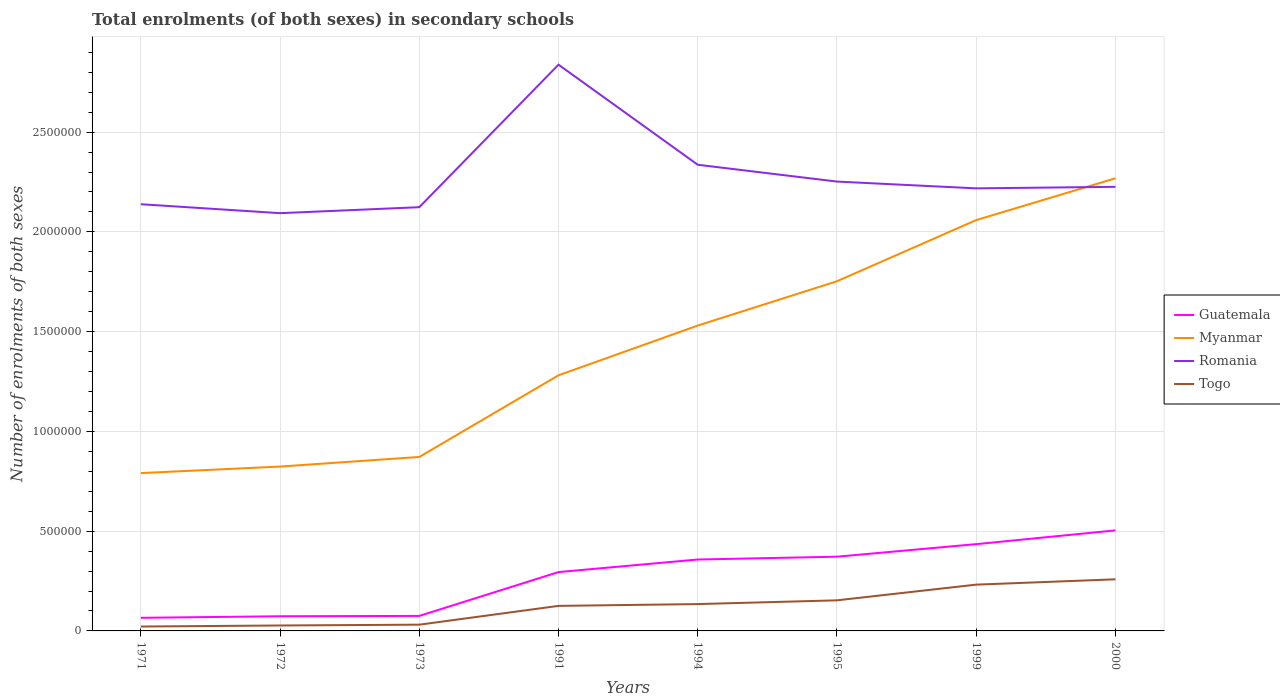How many different coloured lines are there?
Your response must be concise. 4. Does the line corresponding to Myanmar intersect with the line corresponding to Romania?
Your answer should be very brief. Yes. Across all years, what is the maximum number of enrolments in secondary schools in Togo?
Give a very brief answer. 2.20e+04. What is the total number of enrolments in secondary schools in Myanmar in the graph?
Your response must be concise. -8.81e+05. What is the difference between the highest and the second highest number of enrolments in secondary schools in Romania?
Your answer should be compact. 7.44e+05. What is the difference between the highest and the lowest number of enrolments in secondary schools in Myanmar?
Provide a short and direct response. 4. How many lines are there?
Your response must be concise. 4. Does the graph contain grids?
Your answer should be compact. Yes. Where does the legend appear in the graph?
Make the answer very short. Center right. How many legend labels are there?
Your answer should be compact. 4. How are the legend labels stacked?
Your answer should be very brief. Vertical. What is the title of the graph?
Your answer should be compact. Total enrolments (of both sexes) in secondary schools. What is the label or title of the Y-axis?
Give a very brief answer. Number of enrolments of both sexes. What is the Number of enrolments of both sexes of Guatemala in 1971?
Ensure brevity in your answer.  6.57e+04. What is the Number of enrolments of both sexes in Myanmar in 1971?
Your answer should be very brief. 7.91e+05. What is the Number of enrolments of both sexes in Romania in 1971?
Your answer should be compact. 2.14e+06. What is the Number of enrolments of both sexes in Togo in 1971?
Your answer should be compact. 2.20e+04. What is the Number of enrolments of both sexes of Guatemala in 1972?
Provide a short and direct response. 7.35e+04. What is the Number of enrolments of both sexes in Myanmar in 1972?
Your response must be concise. 8.24e+05. What is the Number of enrolments of both sexes of Romania in 1972?
Provide a succinct answer. 2.09e+06. What is the Number of enrolments of both sexes in Togo in 1972?
Provide a short and direct response. 2.73e+04. What is the Number of enrolments of both sexes of Guatemala in 1973?
Give a very brief answer. 7.52e+04. What is the Number of enrolments of both sexes in Myanmar in 1973?
Give a very brief answer. 8.72e+05. What is the Number of enrolments of both sexes of Romania in 1973?
Your answer should be very brief. 2.12e+06. What is the Number of enrolments of both sexes of Togo in 1973?
Give a very brief answer. 3.13e+04. What is the Number of enrolments of both sexes of Guatemala in 1991?
Your answer should be very brief. 2.95e+05. What is the Number of enrolments of both sexes of Myanmar in 1991?
Offer a terse response. 1.28e+06. What is the Number of enrolments of both sexes in Romania in 1991?
Give a very brief answer. 2.84e+06. What is the Number of enrolments of both sexes in Togo in 1991?
Offer a very short reply. 1.26e+05. What is the Number of enrolments of both sexes of Guatemala in 1994?
Provide a succinct answer. 3.58e+05. What is the Number of enrolments of both sexes of Myanmar in 1994?
Provide a succinct answer. 1.53e+06. What is the Number of enrolments of both sexes in Romania in 1994?
Make the answer very short. 2.34e+06. What is the Number of enrolments of both sexes in Togo in 1994?
Keep it short and to the point. 1.35e+05. What is the Number of enrolments of both sexes in Guatemala in 1995?
Ensure brevity in your answer.  3.72e+05. What is the Number of enrolments of both sexes in Myanmar in 1995?
Give a very brief answer. 1.75e+06. What is the Number of enrolments of both sexes of Romania in 1995?
Give a very brief answer. 2.25e+06. What is the Number of enrolments of both sexes of Togo in 1995?
Make the answer very short. 1.53e+05. What is the Number of enrolments of both sexes in Guatemala in 1999?
Keep it short and to the point. 4.35e+05. What is the Number of enrolments of both sexes of Myanmar in 1999?
Your answer should be very brief. 2.06e+06. What is the Number of enrolments of both sexes of Romania in 1999?
Your response must be concise. 2.22e+06. What is the Number of enrolments of both sexes in Togo in 1999?
Offer a very short reply. 2.32e+05. What is the Number of enrolments of both sexes in Guatemala in 2000?
Give a very brief answer. 5.04e+05. What is the Number of enrolments of both sexes of Myanmar in 2000?
Provide a succinct answer. 2.27e+06. What is the Number of enrolments of both sexes of Romania in 2000?
Your answer should be very brief. 2.23e+06. What is the Number of enrolments of both sexes in Togo in 2000?
Your answer should be compact. 2.59e+05. Across all years, what is the maximum Number of enrolments of both sexes of Guatemala?
Provide a short and direct response. 5.04e+05. Across all years, what is the maximum Number of enrolments of both sexes in Myanmar?
Make the answer very short. 2.27e+06. Across all years, what is the maximum Number of enrolments of both sexes in Romania?
Keep it short and to the point. 2.84e+06. Across all years, what is the maximum Number of enrolments of both sexes of Togo?
Offer a terse response. 2.59e+05. Across all years, what is the minimum Number of enrolments of both sexes of Guatemala?
Your answer should be very brief. 6.57e+04. Across all years, what is the minimum Number of enrolments of both sexes of Myanmar?
Ensure brevity in your answer.  7.91e+05. Across all years, what is the minimum Number of enrolments of both sexes of Romania?
Offer a very short reply. 2.09e+06. Across all years, what is the minimum Number of enrolments of both sexes in Togo?
Give a very brief answer. 2.20e+04. What is the total Number of enrolments of both sexes of Guatemala in the graph?
Provide a short and direct response. 2.18e+06. What is the total Number of enrolments of both sexes in Myanmar in the graph?
Make the answer very short. 1.14e+07. What is the total Number of enrolments of both sexes in Romania in the graph?
Your answer should be compact. 1.82e+07. What is the total Number of enrolments of both sexes of Togo in the graph?
Ensure brevity in your answer.  9.85e+05. What is the difference between the Number of enrolments of both sexes in Guatemala in 1971 and that in 1972?
Your answer should be very brief. -7798. What is the difference between the Number of enrolments of both sexes of Myanmar in 1971 and that in 1972?
Your answer should be compact. -3.27e+04. What is the difference between the Number of enrolments of both sexes of Romania in 1971 and that in 1972?
Give a very brief answer. 4.49e+04. What is the difference between the Number of enrolments of both sexes of Togo in 1971 and that in 1972?
Your response must be concise. -5252. What is the difference between the Number of enrolments of both sexes in Guatemala in 1971 and that in 1973?
Ensure brevity in your answer.  -9447. What is the difference between the Number of enrolments of both sexes of Myanmar in 1971 and that in 1973?
Keep it short and to the point. -8.08e+04. What is the difference between the Number of enrolments of both sexes in Romania in 1971 and that in 1973?
Your answer should be compact. 1.49e+04. What is the difference between the Number of enrolments of both sexes in Togo in 1971 and that in 1973?
Your response must be concise. -9285. What is the difference between the Number of enrolments of both sexes in Guatemala in 1971 and that in 1991?
Give a very brief answer. -2.29e+05. What is the difference between the Number of enrolments of both sexes of Myanmar in 1971 and that in 1991?
Provide a succinct answer. -4.90e+05. What is the difference between the Number of enrolments of both sexes in Romania in 1971 and that in 1991?
Keep it short and to the point. -6.99e+05. What is the difference between the Number of enrolments of both sexes in Togo in 1971 and that in 1991?
Your answer should be compact. -1.04e+05. What is the difference between the Number of enrolments of both sexes in Guatemala in 1971 and that in 1994?
Offer a very short reply. -2.92e+05. What is the difference between the Number of enrolments of both sexes of Myanmar in 1971 and that in 1994?
Provide a succinct answer. -7.39e+05. What is the difference between the Number of enrolments of both sexes of Romania in 1971 and that in 1994?
Provide a succinct answer. -1.98e+05. What is the difference between the Number of enrolments of both sexes of Togo in 1971 and that in 1994?
Offer a terse response. -1.13e+05. What is the difference between the Number of enrolments of both sexes in Guatemala in 1971 and that in 1995?
Provide a short and direct response. -3.06e+05. What is the difference between the Number of enrolments of both sexes in Myanmar in 1971 and that in 1995?
Offer a very short reply. -9.61e+05. What is the difference between the Number of enrolments of both sexes of Romania in 1971 and that in 1995?
Your response must be concise. -1.14e+05. What is the difference between the Number of enrolments of both sexes of Togo in 1971 and that in 1995?
Provide a succinct answer. -1.31e+05. What is the difference between the Number of enrolments of both sexes of Guatemala in 1971 and that in 1999?
Provide a short and direct response. -3.69e+05. What is the difference between the Number of enrolments of both sexes in Myanmar in 1971 and that in 1999?
Make the answer very short. -1.27e+06. What is the difference between the Number of enrolments of both sexes of Romania in 1971 and that in 1999?
Ensure brevity in your answer.  -7.95e+04. What is the difference between the Number of enrolments of both sexes in Togo in 1971 and that in 1999?
Offer a terse response. -2.10e+05. What is the difference between the Number of enrolments of both sexes of Guatemala in 1971 and that in 2000?
Ensure brevity in your answer.  -4.38e+05. What is the difference between the Number of enrolments of both sexes in Myanmar in 1971 and that in 2000?
Your response must be concise. -1.48e+06. What is the difference between the Number of enrolments of both sexes of Romania in 1971 and that in 2000?
Provide a succinct answer. -8.71e+04. What is the difference between the Number of enrolments of both sexes in Togo in 1971 and that in 2000?
Ensure brevity in your answer.  -2.37e+05. What is the difference between the Number of enrolments of both sexes of Guatemala in 1972 and that in 1973?
Provide a succinct answer. -1649. What is the difference between the Number of enrolments of both sexes in Myanmar in 1972 and that in 1973?
Offer a very short reply. -4.82e+04. What is the difference between the Number of enrolments of both sexes in Romania in 1972 and that in 1973?
Ensure brevity in your answer.  -3.00e+04. What is the difference between the Number of enrolments of both sexes of Togo in 1972 and that in 1973?
Make the answer very short. -4033. What is the difference between the Number of enrolments of both sexes of Guatemala in 1972 and that in 1991?
Give a very brief answer. -2.21e+05. What is the difference between the Number of enrolments of both sexes in Myanmar in 1972 and that in 1991?
Your answer should be compact. -4.57e+05. What is the difference between the Number of enrolments of both sexes in Romania in 1972 and that in 1991?
Give a very brief answer. -7.44e+05. What is the difference between the Number of enrolments of both sexes in Togo in 1972 and that in 1991?
Your response must be concise. -9.83e+04. What is the difference between the Number of enrolments of both sexes of Guatemala in 1972 and that in 1994?
Offer a terse response. -2.84e+05. What is the difference between the Number of enrolments of both sexes in Myanmar in 1972 and that in 1994?
Provide a short and direct response. -7.07e+05. What is the difference between the Number of enrolments of both sexes of Romania in 1972 and that in 1994?
Your answer should be very brief. -2.43e+05. What is the difference between the Number of enrolments of both sexes of Togo in 1972 and that in 1994?
Offer a terse response. -1.07e+05. What is the difference between the Number of enrolments of both sexes in Guatemala in 1972 and that in 1995?
Your answer should be very brief. -2.98e+05. What is the difference between the Number of enrolments of both sexes of Myanmar in 1972 and that in 1995?
Ensure brevity in your answer.  -9.29e+05. What is the difference between the Number of enrolments of both sexes of Romania in 1972 and that in 1995?
Ensure brevity in your answer.  -1.58e+05. What is the difference between the Number of enrolments of both sexes of Togo in 1972 and that in 1995?
Your response must be concise. -1.26e+05. What is the difference between the Number of enrolments of both sexes of Guatemala in 1972 and that in 1999?
Offer a terse response. -3.61e+05. What is the difference between the Number of enrolments of both sexes in Myanmar in 1972 and that in 1999?
Keep it short and to the point. -1.24e+06. What is the difference between the Number of enrolments of both sexes in Romania in 1972 and that in 1999?
Keep it short and to the point. -1.24e+05. What is the difference between the Number of enrolments of both sexes in Togo in 1972 and that in 1999?
Your response must be concise. -2.05e+05. What is the difference between the Number of enrolments of both sexes of Guatemala in 1972 and that in 2000?
Ensure brevity in your answer.  -4.30e+05. What is the difference between the Number of enrolments of both sexes of Myanmar in 1972 and that in 2000?
Give a very brief answer. -1.44e+06. What is the difference between the Number of enrolments of both sexes in Romania in 1972 and that in 2000?
Provide a succinct answer. -1.32e+05. What is the difference between the Number of enrolments of both sexes of Togo in 1972 and that in 2000?
Offer a very short reply. -2.31e+05. What is the difference between the Number of enrolments of both sexes in Guatemala in 1973 and that in 1991?
Provide a short and direct response. -2.20e+05. What is the difference between the Number of enrolments of both sexes of Myanmar in 1973 and that in 1991?
Keep it short and to the point. -4.09e+05. What is the difference between the Number of enrolments of both sexes in Romania in 1973 and that in 1991?
Ensure brevity in your answer.  -7.14e+05. What is the difference between the Number of enrolments of both sexes in Togo in 1973 and that in 1991?
Give a very brief answer. -9.43e+04. What is the difference between the Number of enrolments of both sexes of Guatemala in 1973 and that in 1994?
Offer a very short reply. -2.83e+05. What is the difference between the Number of enrolments of both sexes in Myanmar in 1973 and that in 1994?
Offer a very short reply. -6.58e+05. What is the difference between the Number of enrolments of both sexes in Romania in 1973 and that in 1994?
Your response must be concise. -2.13e+05. What is the difference between the Number of enrolments of both sexes in Togo in 1973 and that in 1994?
Give a very brief answer. -1.03e+05. What is the difference between the Number of enrolments of both sexes in Guatemala in 1973 and that in 1995?
Ensure brevity in your answer.  -2.97e+05. What is the difference between the Number of enrolments of both sexes of Myanmar in 1973 and that in 1995?
Provide a short and direct response. -8.81e+05. What is the difference between the Number of enrolments of both sexes of Romania in 1973 and that in 1995?
Provide a succinct answer. -1.28e+05. What is the difference between the Number of enrolments of both sexes of Togo in 1973 and that in 1995?
Keep it short and to the point. -1.22e+05. What is the difference between the Number of enrolments of both sexes in Guatemala in 1973 and that in 1999?
Provide a succinct answer. -3.60e+05. What is the difference between the Number of enrolments of both sexes of Myanmar in 1973 and that in 1999?
Offer a very short reply. -1.19e+06. What is the difference between the Number of enrolments of both sexes of Romania in 1973 and that in 1999?
Make the answer very short. -9.44e+04. What is the difference between the Number of enrolments of both sexes in Togo in 1973 and that in 1999?
Your response must be concise. -2.01e+05. What is the difference between the Number of enrolments of both sexes in Guatemala in 1973 and that in 2000?
Give a very brief answer. -4.29e+05. What is the difference between the Number of enrolments of both sexes in Myanmar in 1973 and that in 2000?
Give a very brief answer. -1.40e+06. What is the difference between the Number of enrolments of both sexes of Romania in 1973 and that in 2000?
Keep it short and to the point. -1.02e+05. What is the difference between the Number of enrolments of both sexes of Togo in 1973 and that in 2000?
Provide a short and direct response. -2.27e+05. What is the difference between the Number of enrolments of both sexes of Guatemala in 1991 and that in 1994?
Give a very brief answer. -6.30e+04. What is the difference between the Number of enrolments of both sexes in Myanmar in 1991 and that in 1994?
Offer a very short reply. -2.49e+05. What is the difference between the Number of enrolments of both sexes of Romania in 1991 and that in 1994?
Make the answer very short. 5.02e+05. What is the difference between the Number of enrolments of both sexes in Togo in 1991 and that in 1994?
Your response must be concise. -9014. What is the difference between the Number of enrolments of both sexes of Guatemala in 1991 and that in 1995?
Give a very brief answer. -7.71e+04. What is the difference between the Number of enrolments of both sexes of Myanmar in 1991 and that in 1995?
Your answer should be very brief. -4.71e+05. What is the difference between the Number of enrolments of both sexes of Romania in 1991 and that in 1995?
Make the answer very short. 5.86e+05. What is the difference between the Number of enrolments of both sexes of Togo in 1991 and that in 1995?
Your answer should be compact. -2.78e+04. What is the difference between the Number of enrolments of both sexes in Guatemala in 1991 and that in 1999?
Keep it short and to the point. -1.40e+05. What is the difference between the Number of enrolments of both sexes of Myanmar in 1991 and that in 1999?
Offer a terse response. -7.78e+05. What is the difference between the Number of enrolments of both sexes in Romania in 1991 and that in 1999?
Provide a short and direct response. 6.20e+05. What is the difference between the Number of enrolments of both sexes of Togo in 1991 and that in 1999?
Provide a succinct answer. -1.06e+05. What is the difference between the Number of enrolments of both sexes in Guatemala in 1991 and that in 2000?
Make the answer very short. -2.09e+05. What is the difference between the Number of enrolments of both sexes of Myanmar in 1991 and that in 2000?
Make the answer very short. -9.87e+05. What is the difference between the Number of enrolments of both sexes in Romania in 1991 and that in 2000?
Offer a terse response. 6.12e+05. What is the difference between the Number of enrolments of both sexes of Togo in 1991 and that in 2000?
Provide a short and direct response. -1.33e+05. What is the difference between the Number of enrolments of both sexes of Guatemala in 1994 and that in 1995?
Give a very brief answer. -1.41e+04. What is the difference between the Number of enrolments of both sexes of Myanmar in 1994 and that in 1995?
Provide a succinct answer. -2.22e+05. What is the difference between the Number of enrolments of both sexes of Romania in 1994 and that in 1995?
Provide a short and direct response. 8.43e+04. What is the difference between the Number of enrolments of both sexes of Togo in 1994 and that in 1995?
Your answer should be compact. -1.88e+04. What is the difference between the Number of enrolments of both sexes of Guatemala in 1994 and that in 1999?
Your answer should be compact. -7.70e+04. What is the difference between the Number of enrolments of both sexes of Myanmar in 1994 and that in 1999?
Provide a short and direct response. -5.29e+05. What is the difference between the Number of enrolments of both sexes of Romania in 1994 and that in 1999?
Offer a terse response. 1.18e+05. What is the difference between the Number of enrolments of both sexes in Togo in 1994 and that in 1999?
Provide a short and direct response. -9.74e+04. What is the difference between the Number of enrolments of both sexes of Guatemala in 1994 and that in 2000?
Make the answer very short. -1.46e+05. What is the difference between the Number of enrolments of both sexes in Myanmar in 1994 and that in 2000?
Ensure brevity in your answer.  -7.38e+05. What is the difference between the Number of enrolments of both sexes in Romania in 1994 and that in 2000?
Ensure brevity in your answer.  1.11e+05. What is the difference between the Number of enrolments of both sexes of Togo in 1994 and that in 2000?
Provide a short and direct response. -1.24e+05. What is the difference between the Number of enrolments of both sexes in Guatemala in 1995 and that in 1999?
Your answer should be compact. -6.29e+04. What is the difference between the Number of enrolments of both sexes of Myanmar in 1995 and that in 1999?
Your response must be concise. -3.06e+05. What is the difference between the Number of enrolments of both sexes of Romania in 1995 and that in 1999?
Your answer should be very brief. 3.40e+04. What is the difference between the Number of enrolments of both sexes of Togo in 1995 and that in 1999?
Give a very brief answer. -7.86e+04. What is the difference between the Number of enrolments of both sexes of Guatemala in 1995 and that in 2000?
Your answer should be very brief. -1.32e+05. What is the difference between the Number of enrolments of both sexes of Myanmar in 1995 and that in 2000?
Offer a terse response. -5.16e+05. What is the difference between the Number of enrolments of both sexes of Romania in 1995 and that in 2000?
Your response must be concise. 2.64e+04. What is the difference between the Number of enrolments of both sexes in Togo in 1995 and that in 2000?
Provide a succinct answer. -1.05e+05. What is the difference between the Number of enrolments of both sexes of Guatemala in 1999 and that in 2000?
Your answer should be very brief. -6.90e+04. What is the difference between the Number of enrolments of both sexes in Myanmar in 1999 and that in 2000?
Offer a very short reply. -2.09e+05. What is the difference between the Number of enrolments of both sexes in Romania in 1999 and that in 2000?
Make the answer very short. -7666. What is the difference between the Number of enrolments of both sexes in Togo in 1999 and that in 2000?
Keep it short and to the point. -2.67e+04. What is the difference between the Number of enrolments of both sexes in Guatemala in 1971 and the Number of enrolments of both sexes in Myanmar in 1972?
Keep it short and to the point. -7.58e+05. What is the difference between the Number of enrolments of both sexes in Guatemala in 1971 and the Number of enrolments of both sexes in Romania in 1972?
Provide a short and direct response. -2.03e+06. What is the difference between the Number of enrolments of both sexes in Guatemala in 1971 and the Number of enrolments of both sexes in Togo in 1972?
Offer a very short reply. 3.85e+04. What is the difference between the Number of enrolments of both sexes of Myanmar in 1971 and the Number of enrolments of both sexes of Romania in 1972?
Ensure brevity in your answer.  -1.30e+06. What is the difference between the Number of enrolments of both sexes in Myanmar in 1971 and the Number of enrolments of both sexes in Togo in 1972?
Make the answer very short. 7.64e+05. What is the difference between the Number of enrolments of both sexes in Romania in 1971 and the Number of enrolments of both sexes in Togo in 1972?
Offer a terse response. 2.11e+06. What is the difference between the Number of enrolments of both sexes of Guatemala in 1971 and the Number of enrolments of both sexes of Myanmar in 1973?
Ensure brevity in your answer.  -8.06e+05. What is the difference between the Number of enrolments of both sexes in Guatemala in 1971 and the Number of enrolments of both sexes in Romania in 1973?
Your response must be concise. -2.06e+06. What is the difference between the Number of enrolments of both sexes of Guatemala in 1971 and the Number of enrolments of both sexes of Togo in 1973?
Offer a very short reply. 3.44e+04. What is the difference between the Number of enrolments of both sexes in Myanmar in 1971 and the Number of enrolments of both sexes in Romania in 1973?
Provide a short and direct response. -1.33e+06. What is the difference between the Number of enrolments of both sexes of Myanmar in 1971 and the Number of enrolments of both sexes of Togo in 1973?
Ensure brevity in your answer.  7.60e+05. What is the difference between the Number of enrolments of both sexes of Romania in 1971 and the Number of enrolments of both sexes of Togo in 1973?
Your answer should be very brief. 2.11e+06. What is the difference between the Number of enrolments of both sexes in Guatemala in 1971 and the Number of enrolments of both sexes in Myanmar in 1991?
Provide a short and direct response. -1.22e+06. What is the difference between the Number of enrolments of both sexes in Guatemala in 1971 and the Number of enrolments of both sexes in Romania in 1991?
Provide a short and direct response. -2.77e+06. What is the difference between the Number of enrolments of both sexes of Guatemala in 1971 and the Number of enrolments of both sexes of Togo in 1991?
Keep it short and to the point. -5.98e+04. What is the difference between the Number of enrolments of both sexes of Myanmar in 1971 and the Number of enrolments of both sexes of Romania in 1991?
Your response must be concise. -2.05e+06. What is the difference between the Number of enrolments of both sexes of Myanmar in 1971 and the Number of enrolments of both sexes of Togo in 1991?
Ensure brevity in your answer.  6.66e+05. What is the difference between the Number of enrolments of both sexes in Romania in 1971 and the Number of enrolments of both sexes in Togo in 1991?
Make the answer very short. 2.01e+06. What is the difference between the Number of enrolments of both sexes in Guatemala in 1971 and the Number of enrolments of both sexes in Myanmar in 1994?
Provide a short and direct response. -1.46e+06. What is the difference between the Number of enrolments of both sexes in Guatemala in 1971 and the Number of enrolments of both sexes in Romania in 1994?
Your response must be concise. -2.27e+06. What is the difference between the Number of enrolments of both sexes of Guatemala in 1971 and the Number of enrolments of both sexes of Togo in 1994?
Provide a succinct answer. -6.89e+04. What is the difference between the Number of enrolments of both sexes of Myanmar in 1971 and the Number of enrolments of both sexes of Romania in 1994?
Ensure brevity in your answer.  -1.55e+06. What is the difference between the Number of enrolments of both sexes in Myanmar in 1971 and the Number of enrolments of both sexes in Togo in 1994?
Offer a very short reply. 6.56e+05. What is the difference between the Number of enrolments of both sexes of Romania in 1971 and the Number of enrolments of both sexes of Togo in 1994?
Keep it short and to the point. 2.00e+06. What is the difference between the Number of enrolments of both sexes in Guatemala in 1971 and the Number of enrolments of both sexes in Myanmar in 1995?
Your answer should be very brief. -1.69e+06. What is the difference between the Number of enrolments of both sexes of Guatemala in 1971 and the Number of enrolments of both sexes of Romania in 1995?
Offer a very short reply. -2.19e+06. What is the difference between the Number of enrolments of both sexes of Guatemala in 1971 and the Number of enrolments of both sexes of Togo in 1995?
Offer a terse response. -8.76e+04. What is the difference between the Number of enrolments of both sexes of Myanmar in 1971 and the Number of enrolments of both sexes of Romania in 1995?
Offer a terse response. -1.46e+06. What is the difference between the Number of enrolments of both sexes of Myanmar in 1971 and the Number of enrolments of both sexes of Togo in 1995?
Provide a short and direct response. 6.38e+05. What is the difference between the Number of enrolments of both sexes of Romania in 1971 and the Number of enrolments of both sexes of Togo in 1995?
Keep it short and to the point. 1.99e+06. What is the difference between the Number of enrolments of both sexes of Guatemala in 1971 and the Number of enrolments of both sexes of Myanmar in 1999?
Your answer should be very brief. -1.99e+06. What is the difference between the Number of enrolments of both sexes of Guatemala in 1971 and the Number of enrolments of both sexes of Romania in 1999?
Provide a short and direct response. -2.15e+06. What is the difference between the Number of enrolments of both sexes in Guatemala in 1971 and the Number of enrolments of both sexes in Togo in 1999?
Provide a succinct answer. -1.66e+05. What is the difference between the Number of enrolments of both sexes in Myanmar in 1971 and the Number of enrolments of both sexes in Romania in 1999?
Give a very brief answer. -1.43e+06. What is the difference between the Number of enrolments of both sexes of Myanmar in 1971 and the Number of enrolments of both sexes of Togo in 1999?
Ensure brevity in your answer.  5.59e+05. What is the difference between the Number of enrolments of both sexes of Romania in 1971 and the Number of enrolments of both sexes of Togo in 1999?
Your answer should be compact. 1.91e+06. What is the difference between the Number of enrolments of both sexes of Guatemala in 1971 and the Number of enrolments of both sexes of Myanmar in 2000?
Your answer should be compact. -2.20e+06. What is the difference between the Number of enrolments of both sexes of Guatemala in 1971 and the Number of enrolments of both sexes of Romania in 2000?
Your response must be concise. -2.16e+06. What is the difference between the Number of enrolments of both sexes in Guatemala in 1971 and the Number of enrolments of both sexes in Togo in 2000?
Your answer should be compact. -1.93e+05. What is the difference between the Number of enrolments of both sexes in Myanmar in 1971 and the Number of enrolments of both sexes in Romania in 2000?
Make the answer very short. -1.43e+06. What is the difference between the Number of enrolments of both sexes of Myanmar in 1971 and the Number of enrolments of both sexes of Togo in 2000?
Give a very brief answer. 5.32e+05. What is the difference between the Number of enrolments of both sexes in Romania in 1971 and the Number of enrolments of both sexes in Togo in 2000?
Give a very brief answer. 1.88e+06. What is the difference between the Number of enrolments of both sexes of Guatemala in 1972 and the Number of enrolments of both sexes of Myanmar in 1973?
Your answer should be compact. -7.98e+05. What is the difference between the Number of enrolments of both sexes of Guatemala in 1972 and the Number of enrolments of both sexes of Romania in 1973?
Ensure brevity in your answer.  -2.05e+06. What is the difference between the Number of enrolments of both sexes of Guatemala in 1972 and the Number of enrolments of both sexes of Togo in 1973?
Keep it short and to the point. 4.22e+04. What is the difference between the Number of enrolments of both sexes in Myanmar in 1972 and the Number of enrolments of both sexes in Romania in 1973?
Provide a short and direct response. -1.30e+06. What is the difference between the Number of enrolments of both sexes of Myanmar in 1972 and the Number of enrolments of both sexes of Togo in 1973?
Provide a short and direct response. 7.92e+05. What is the difference between the Number of enrolments of both sexes in Romania in 1972 and the Number of enrolments of both sexes in Togo in 1973?
Provide a short and direct response. 2.06e+06. What is the difference between the Number of enrolments of both sexes in Guatemala in 1972 and the Number of enrolments of both sexes in Myanmar in 1991?
Your answer should be very brief. -1.21e+06. What is the difference between the Number of enrolments of both sexes in Guatemala in 1972 and the Number of enrolments of both sexes in Romania in 1991?
Your answer should be very brief. -2.76e+06. What is the difference between the Number of enrolments of both sexes of Guatemala in 1972 and the Number of enrolments of both sexes of Togo in 1991?
Offer a very short reply. -5.20e+04. What is the difference between the Number of enrolments of both sexes in Myanmar in 1972 and the Number of enrolments of both sexes in Romania in 1991?
Your response must be concise. -2.01e+06. What is the difference between the Number of enrolments of both sexes of Myanmar in 1972 and the Number of enrolments of both sexes of Togo in 1991?
Provide a short and direct response. 6.98e+05. What is the difference between the Number of enrolments of both sexes in Romania in 1972 and the Number of enrolments of both sexes in Togo in 1991?
Ensure brevity in your answer.  1.97e+06. What is the difference between the Number of enrolments of both sexes in Guatemala in 1972 and the Number of enrolments of both sexes in Myanmar in 1994?
Offer a very short reply. -1.46e+06. What is the difference between the Number of enrolments of both sexes of Guatemala in 1972 and the Number of enrolments of both sexes of Romania in 1994?
Your answer should be very brief. -2.26e+06. What is the difference between the Number of enrolments of both sexes in Guatemala in 1972 and the Number of enrolments of both sexes in Togo in 1994?
Your response must be concise. -6.11e+04. What is the difference between the Number of enrolments of both sexes of Myanmar in 1972 and the Number of enrolments of both sexes of Romania in 1994?
Make the answer very short. -1.51e+06. What is the difference between the Number of enrolments of both sexes in Myanmar in 1972 and the Number of enrolments of both sexes in Togo in 1994?
Your answer should be compact. 6.89e+05. What is the difference between the Number of enrolments of both sexes of Romania in 1972 and the Number of enrolments of both sexes of Togo in 1994?
Keep it short and to the point. 1.96e+06. What is the difference between the Number of enrolments of both sexes of Guatemala in 1972 and the Number of enrolments of both sexes of Myanmar in 1995?
Give a very brief answer. -1.68e+06. What is the difference between the Number of enrolments of both sexes of Guatemala in 1972 and the Number of enrolments of both sexes of Romania in 1995?
Your response must be concise. -2.18e+06. What is the difference between the Number of enrolments of both sexes in Guatemala in 1972 and the Number of enrolments of both sexes in Togo in 1995?
Your response must be concise. -7.98e+04. What is the difference between the Number of enrolments of both sexes of Myanmar in 1972 and the Number of enrolments of both sexes of Romania in 1995?
Keep it short and to the point. -1.43e+06. What is the difference between the Number of enrolments of both sexes in Myanmar in 1972 and the Number of enrolments of both sexes in Togo in 1995?
Offer a terse response. 6.70e+05. What is the difference between the Number of enrolments of both sexes in Romania in 1972 and the Number of enrolments of both sexes in Togo in 1995?
Offer a very short reply. 1.94e+06. What is the difference between the Number of enrolments of both sexes in Guatemala in 1972 and the Number of enrolments of both sexes in Myanmar in 1999?
Your answer should be compact. -1.99e+06. What is the difference between the Number of enrolments of both sexes in Guatemala in 1972 and the Number of enrolments of both sexes in Romania in 1999?
Your response must be concise. -2.14e+06. What is the difference between the Number of enrolments of both sexes of Guatemala in 1972 and the Number of enrolments of both sexes of Togo in 1999?
Offer a very short reply. -1.58e+05. What is the difference between the Number of enrolments of both sexes in Myanmar in 1972 and the Number of enrolments of both sexes in Romania in 1999?
Your answer should be very brief. -1.39e+06. What is the difference between the Number of enrolments of both sexes in Myanmar in 1972 and the Number of enrolments of both sexes in Togo in 1999?
Provide a short and direct response. 5.92e+05. What is the difference between the Number of enrolments of both sexes in Romania in 1972 and the Number of enrolments of both sexes in Togo in 1999?
Keep it short and to the point. 1.86e+06. What is the difference between the Number of enrolments of both sexes of Guatemala in 1972 and the Number of enrolments of both sexes of Myanmar in 2000?
Offer a terse response. -2.19e+06. What is the difference between the Number of enrolments of both sexes in Guatemala in 1972 and the Number of enrolments of both sexes in Romania in 2000?
Give a very brief answer. -2.15e+06. What is the difference between the Number of enrolments of both sexes in Guatemala in 1972 and the Number of enrolments of both sexes in Togo in 2000?
Keep it short and to the point. -1.85e+05. What is the difference between the Number of enrolments of both sexes in Myanmar in 1972 and the Number of enrolments of both sexes in Romania in 2000?
Offer a terse response. -1.40e+06. What is the difference between the Number of enrolments of both sexes in Myanmar in 1972 and the Number of enrolments of both sexes in Togo in 2000?
Your answer should be very brief. 5.65e+05. What is the difference between the Number of enrolments of both sexes in Romania in 1972 and the Number of enrolments of both sexes in Togo in 2000?
Your answer should be very brief. 1.83e+06. What is the difference between the Number of enrolments of both sexes of Guatemala in 1973 and the Number of enrolments of both sexes of Myanmar in 1991?
Offer a terse response. -1.21e+06. What is the difference between the Number of enrolments of both sexes of Guatemala in 1973 and the Number of enrolments of both sexes of Romania in 1991?
Ensure brevity in your answer.  -2.76e+06. What is the difference between the Number of enrolments of both sexes in Guatemala in 1973 and the Number of enrolments of both sexes in Togo in 1991?
Your response must be concise. -5.04e+04. What is the difference between the Number of enrolments of both sexes of Myanmar in 1973 and the Number of enrolments of both sexes of Romania in 1991?
Offer a terse response. -1.97e+06. What is the difference between the Number of enrolments of both sexes in Myanmar in 1973 and the Number of enrolments of both sexes in Togo in 1991?
Ensure brevity in your answer.  7.46e+05. What is the difference between the Number of enrolments of both sexes in Romania in 1973 and the Number of enrolments of both sexes in Togo in 1991?
Keep it short and to the point. 2.00e+06. What is the difference between the Number of enrolments of both sexes of Guatemala in 1973 and the Number of enrolments of both sexes of Myanmar in 1994?
Offer a very short reply. -1.46e+06. What is the difference between the Number of enrolments of both sexes of Guatemala in 1973 and the Number of enrolments of both sexes of Romania in 1994?
Keep it short and to the point. -2.26e+06. What is the difference between the Number of enrolments of both sexes in Guatemala in 1973 and the Number of enrolments of both sexes in Togo in 1994?
Your answer should be compact. -5.94e+04. What is the difference between the Number of enrolments of both sexes of Myanmar in 1973 and the Number of enrolments of both sexes of Romania in 1994?
Provide a succinct answer. -1.46e+06. What is the difference between the Number of enrolments of both sexes in Myanmar in 1973 and the Number of enrolments of both sexes in Togo in 1994?
Make the answer very short. 7.37e+05. What is the difference between the Number of enrolments of both sexes in Romania in 1973 and the Number of enrolments of both sexes in Togo in 1994?
Give a very brief answer. 1.99e+06. What is the difference between the Number of enrolments of both sexes of Guatemala in 1973 and the Number of enrolments of both sexes of Myanmar in 1995?
Your response must be concise. -1.68e+06. What is the difference between the Number of enrolments of both sexes in Guatemala in 1973 and the Number of enrolments of both sexes in Romania in 1995?
Your answer should be compact. -2.18e+06. What is the difference between the Number of enrolments of both sexes of Guatemala in 1973 and the Number of enrolments of both sexes of Togo in 1995?
Ensure brevity in your answer.  -7.82e+04. What is the difference between the Number of enrolments of both sexes of Myanmar in 1973 and the Number of enrolments of both sexes of Romania in 1995?
Ensure brevity in your answer.  -1.38e+06. What is the difference between the Number of enrolments of both sexes of Myanmar in 1973 and the Number of enrolments of both sexes of Togo in 1995?
Give a very brief answer. 7.19e+05. What is the difference between the Number of enrolments of both sexes of Romania in 1973 and the Number of enrolments of both sexes of Togo in 1995?
Offer a terse response. 1.97e+06. What is the difference between the Number of enrolments of both sexes of Guatemala in 1973 and the Number of enrolments of both sexes of Myanmar in 1999?
Give a very brief answer. -1.98e+06. What is the difference between the Number of enrolments of both sexes of Guatemala in 1973 and the Number of enrolments of both sexes of Romania in 1999?
Offer a very short reply. -2.14e+06. What is the difference between the Number of enrolments of both sexes of Guatemala in 1973 and the Number of enrolments of both sexes of Togo in 1999?
Your answer should be compact. -1.57e+05. What is the difference between the Number of enrolments of both sexes of Myanmar in 1973 and the Number of enrolments of both sexes of Romania in 1999?
Ensure brevity in your answer.  -1.35e+06. What is the difference between the Number of enrolments of both sexes in Myanmar in 1973 and the Number of enrolments of both sexes in Togo in 1999?
Ensure brevity in your answer.  6.40e+05. What is the difference between the Number of enrolments of both sexes in Romania in 1973 and the Number of enrolments of both sexes in Togo in 1999?
Your answer should be compact. 1.89e+06. What is the difference between the Number of enrolments of both sexes of Guatemala in 1973 and the Number of enrolments of both sexes of Myanmar in 2000?
Your answer should be very brief. -2.19e+06. What is the difference between the Number of enrolments of both sexes of Guatemala in 1973 and the Number of enrolments of both sexes of Romania in 2000?
Provide a succinct answer. -2.15e+06. What is the difference between the Number of enrolments of both sexes of Guatemala in 1973 and the Number of enrolments of both sexes of Togo in 2000?
Your answer should be very brief. -1.84e+05. What is the difference between the Number of enrolments of both sexes in Myanmar in 1973 and the Number of enrolments of both sexes in Romania in 2000?
Your response must be concise. -1.35e+06. What is the difference between the Number of enrolments of both sexes in Myanmar in 1973 and the Number of enrolments of both sexes in Togo in 2000?
Your answer should be very brief. 6.13e+05. What is the difference between the Number of enrolments of both sexes in Romania in 1973 and the Number of enrolments of both sexes in Togo in 2000?
Provide a succinct answer. 1.86e+06. What is the difference between the Number of enrolments of both sexes in Guatemala in 1991 and the Number of enrolments of both sexes in Myanmar in 1994?
Offer a very short reply. -1.24e+06. What is the difference between the Number of enrolments of both sexes in Guatemala in 1991 and the Number of enrolments of both sexes in Romania in 1994?
Keep it short and to the point. -2.04e+06. What is the difference between the Number of enrolments of both sexes in Guatemala in 1991 and the Number of enrolments of both sexes in Togo in 1994?
Your response must be concise. 1.60e+05. What is the difference between the Number of enrolments of both sexes in Myanmar in 1991 and the Number of enrolments of both sexes in Romania in 1994?
Offer a very short reply. -1.06e+06. What is the difference between the Number of enrolments of both sexes in Myanmar in 1991 and the Number of enrolments of both sexes in Togo in 1994?
Keep it short and to the point. 1.15e+06. What is the difference between the Number of enrolments of both sexes in Romania in 1991 and the Number of enrolments of both sexes in Togo in 1994?
Your response must be concise. 2.70e+06. What is the difference between the Number of enrolments of both sexes in Guatemala in 1991 and the Number of enrolments of both sexes in Myanmar in 1995?
Your answer should be compact. -1.46e+06. What is the difference between the Number of enrolments of both sexes of Guatemala in 1991 and the Number of enrolments of both sexes of Romania in 1995?
Offer a very short reply. -1.96e+06. What is the difference between the Number of enrolments of both sexes of Guatemala in 1991 and the Number of enrolments of both sexes of Togo in 1995?
Keep it short and to the point. 1.42e+05. What is the difference between the Number of enrolments of both sexes in Myanmar in 1991 and the Number of enrolments of both sexes in Romania in 1995?
Your response must be concise. -9.71e+05. What is the difference between the Number of enrolments of both sexes in Myanmar in 1991 and the Number of enrolments of both sexes in Togo in 1995?
Ensure brevity in your answer.  1.13e+06. What is the difference between the Number of enrolments of both sexes in Romania in 1991 and the Number of enrolments of both sexes in Togo in 1995?
Your answer should be very brief. 2.68e+06. What is the difference between the Number of enrolments of both sexes of Guatemala in 1991 and the Number of enrolments of both sexes of Myanmar in 1999?
Make the answer very short. -1.76e+06. What is the difference between the Number of enrolments of both sexes in Guatemala in 1991 and the Number of enrolments of both sexes in Romania in 1999?
Offer a terse response. -1.92e+06. What is the difference between the Number of enrolments of both sexes in Guatemala in 1991 and the Number of enrolments of both sexes in Togo in 1999?
Offer a terse response. 6.30e+04. What is the difference between the Number of enrolments of both sexes in Myanmar in 1991 and the Number of enrolments of both sexes in Romania in 1999?
Your answer should be compact. -9.37e+05. What is the difference between the Number of enrolments of both sexes in Myanmar in 1991 and the Number of enrolments of both sexes in Togo in 1999?
Provide a short and direct response. 1.05e+06. What is the difference between the Number of enrolments of both sexes of Romania in 1991 and the Number of enrolments of both sexes of Togo in 1999?
Keep it short and to the point. 2.61e+06. What is the difference between the Number of enrolments of both sexes in Guatemala in 1991 and the Number of enrolments of both sexes in Myanmar in 2000?
Your answer should be very brief. -1.97e+06. What is the difference between the Number of enrolments of both sexes in Guatemala in 1991 and the Number of enrolments of both sexes in Romania in 2000?
Your response must be concise. -1.93e+06. What is the difference between the Number of enrolments of both sexes in Guatemala in 1991 and the Number of enrolments of both sexes in Togo in 2000?
Provide a short and direct response. 3.62e+04. What is the difference between the Number of enrolments of both sexes of Myanmar in 1991 and the Number of enrolments of both sexes of Romania in 2000?
Provide a short and direct response. -9.45e+05. What is the difference between the Number of enrolments of both sexes of Myanmar in 1991 and the Number of enrolments of both sexes of Togo in 2000?
Ensure brevity in your answer.  1.02e+06. What is the difference between the Number of enrolments of both sexes of Romania in 1991 and the Number of enrolments of both sexes of Togo in 2000?
Your answer should be very brief. 2.58e+06. What is the difference between the Number of enrolments of both sexes in Guatemala in 1994 and the Number of enrolments of both sexes in Myanmar in 1995?
Provide a short and direct response. -1.39e+06. What is the difference between the Number of enrolments of both sexes in Guatemala in 1994 and the Number of enrolments of both sexes in Romania in 1995?
Ensure brevity in your answer.  -1.89e+06. What is the difference between the Number of enrolments of both sexes of Guatemala in 1994 and the Number of enrolments of both sexes of Togo in 1995?
Offer a very short reply. 2.05e+05. What is the difference between the Number of enrolments of both sexes in Myanmar in 1994 and the Number of enrolments of both sexes in Romania in 1995?
Your response must be concise. -7.22e+05. What is the difference between the Number of enrolments of both sexes in Myanmar in 1994 and the Number of enrolments of both sexes in Togo in 1995?
Your answer should be very brief. 1.38e+06. What is the difference between the Number of enrolments of both sexes in Romania in 1994 and the Number of enrolments of both sexes in Togo in 1995?
Offer a terse response. 2.18e+06. What is the difference between the Number of enrolments of both sexes in Guatemala in 1994 and the Number of enrolments of both sexes in Myanmar in 1999?
Provide a short and direct response. -1.70e+06. What is the difference between the Number of enrolments of both sexes of Guatemala in 1994 and the Number of enrolments of both sexes of Romania in 1999?
Offer a terse response. -1.86e+06. What is the difference between the Number of enrolments of both sexes of Guatemala in 1994 and the Number of enrolments of both sexes of Togo in 1999?
Keep it short and to the point. 1.26e+05. What is the difference between the Number of enrolments of both sexes in Myanmar in 1994 and the Number of enrolments of both sexes in Romania in 1999?
Offer a terse response. -6.88e+05. What is the difference between the Number of enrolments of both sexes in Myanmar in 1994 and the Number of enrolments of both sexes in Togo in 1999?
Your response must be concise. 1.30e+06. What is the difference between the Number of enrolments of both sexes of Romania in 1994 and the Number of enrolments of both sexes of Togo in 1999?
Your answer should be compact. 2.10e+06. What is the difference between the Number of enrolments of both sexes of Guatemala in 1994 and the Number of enrolments of both sexes of Myanmar in 2000?
Your answer should be very brief. -1.91e+06. What is the difference between the Number of enrolments of both sexes of Guatemala in 1994 and the Number of enrolments of both sexes of Romania in 2000?
Your answer should be very brief. -1.87e+06. What is the difference between the Number of enrolments of both sexes of Guatemala in 1994 and the Number of enrolments of both sexes of Togo in 2000?
Give a very brief answer. 9.92e+04. What is the difference between the Number of enrolments of both sexes of Myanmar in 1994 and the Number of enrolments of both sexes of Romania in 2000?
Your response must be concise. -6.95e+05. What is the difference between the Number of enrolments of both sexes of Myanmar in 1994 and the Number of enrolments of both sexes of Togo in 2000?
Your answer should be very brief. 1.27e+06. What is the difference between the Number of enrolments of both sexes of Romania in 1994 and the Number of enrolments of both sexes of Togo in 2000?
Provide a short and direct response. 2.08e+06. What is the difference between the Number of enrolments of both sexes in Guatemala in 1995 and the Number of enrolments of both sexes in Myanmar in 1999?
Offer a very short reply. -1.69e+06. What is the difference between the Number of enrolments of both sexes in Guatemala in 1995 and the Number of enrolments of both sexes in Romania in 1999?
Make the answer very short. -1.85e+06. What is the difference between the Number of enrolments of both sexes of Guatemala in 1995 and the Number of enrolments of both sexes of Togo in 1999?
Your answer should be very brief. 1.40e+05. What is the difference between the Number of enrolments of both sexes in Myanmar in 1995 and the Number of enrolments of both sexes in Romania in 1999?
Provide a succinct answer. -4.66e+05. What is the difference between the Number of enrolments of both sexes of Myanmar in 1995 and the Number of enrolments of both sexes of Togo in 1999?
Ensure brevity in your answer.  1.52e+06. What is the difference between the Number of enrolments of both sexes of Romania in 1995 and the Number of enrolments of both sexes of Togo in 1999?
Give a very brief answer. 2.02e+06. What is the difference between the Number of enrolments of both sexes in Guatemala in 1995 and the Number of enrolments of both sexes in Myanmar in 2000?
Ensure brevity in your answer.  -1.90e+06. What is the difference between the Number of enrolments of both sexes in Guatemala in 1995 and the Number of enrolments of both sexes in Romania in 2000?
Provide a short and direct response. -1.85e+06. What is the difference between the Number of enrolments of both sexes of Guatemala in 1995 and the Number of enrolments of both sexes of Togo in 2000?
Offer a very short reply. 1.13e+05. What is the difference between the Number of enrolments of both sexes in Myanmar in 1995 and the Number of enrolments of both sexes in Romania in 2000?
Ensure brevity in your answer.  -4.73e+05. What is the difference between the Number of enrolments of both sexes of Myanmar in 1995 and the Number of enrolments of both sexes of Togo in 2000?
Offer a very short reply. 1.49e+06. What is the difference between the Number of enrolments of both sexes in Romania in 1995 and the Number of enrolments of both sexes in Togo in 2000?
Provide a short and direct response. 1.99e+06. What is the difference between the Number of enrolments of both sexes of Guatemala in 1999 and the Number of enrolments of both sexes of Myanmar in 2000?
Ensure brevity in your answer.  -1.83e+06. What is the difference between the Number of enrolments of both sexes in Guatemala in 1999 and the Number of enrolments of both sexes in Romania in 2000?
Make the answer very short. -1.79e+06. What is the difference between the Number of enrolments of both sexes of Guatemala in 1999 and the Number of enrolments of both sexes of Togo in 2000?
Provide a short and direct response. 1.76e+05. What is the difference between the Number of enrolments of both sexes of Myanmar in 1999 and the Number of enrolments of both sexes of Romania in 2000?
Offer a very short reply. -1.67e+05. What is the difference between the Number of enrolments of both sexes in Myanmar in 1999 and the Number of enrolments of both sexes in Togo in 2000?
Keep it short and to the point. 1.80e+06. What is the difference between the Number of enrolments of both sexes in Romania in 1999 and the Number of enrolments of both sexes in Togo in 2000?
Give a very brief answer. 1.96e+06. What is the average Number of enrolments of both sexes of Guatemala per year?
Your response must be concise. 2.72e+05. What is the average Number of enrolments of both sexes of Myanmar per year?
Offer a terse response. 1.42e+06. What is the average Number of enrolments of both sexes in Romania per year?
Give a very brief answer. 2.28e+06. What is the average Number of enrolments of both sexes in Togo per year?
Your response must be concise. 1.23e+05. In the year 1971, what is the difference between the Number of enrolments of both sexes in Guatemala and Number of enrolments of both sexes in Myanmar?
Your response must be concise. -7.25e+05. In the year 1971, what is the difference between the Number of enrolments of both sexes of Guatemala and Number of enrolments of both sexes of Romania?
Offer a very short reply. -2.07e+06. In the year 1971, what is the difference between the Number of enrolments of both sexes of Guatemala and Number of enrolments of both sexes of Togo?
Give a very brief answer. 4.37e+04. In the year 1971, what is the difference between the Number of enrolments of both sexes of Myanmar and Number of enrolments of both sexes of Romania?
Your response must be concise. -1.35e+06. In the year 1971, what is the difference between the Number of enrolments of both sexes of Myanmar and Number of enrolments of both sexes of Togo?
Provide a short and direct response. 7.69e+05. In the year 1971, what is the difference between the Number of enrolments of both sexes of Romania and Number of enrolments of both sexes of Togo?
Your answer should be compact. 2.12e+06. In the year 1972, what is the difference between the Number of enrolments of both sexes in Guatemala and Number of enrolments of both sexes in Myanmar?
Give a very brief answer. -7.50e+05. In the year 1972, what is the difference between the Number of enrolments of both sexes of Guatemala and Number of enrolments of both sexes of Romania?
Make the answer very short. -2.02e+06. In the year 1972, what is the difference between the Number of enrolments of both sexes in Guatemala and Number of enrolments of both sexes in Togo?
Your answer should be very brief. 4.63e+04. In the year 1972, what is the difference between the Number of enrolments of both sexes in Myanmar and Number of enrolments of both sexes in Romania?
Your response must be concise. -1.27e+06. In the year 1972, what is the difference between the Number of enrolments of both sexes of Myanmar and Number of enrolments of both sexes of Togo?
Your response must be concise. 7.96e+05. In the year 1972, what is the difference between the Number of enrolments of both sexes of Romania and Number of enrolments of both sexes of Togo?
Keep it short and to the point. 2.07e+06. In the year 1973, what is the difference between the Number of enrolments of both sexes in Guatemala and Number of enrolments of both sexes in Myanmar?
Offer a terse response. -7.97e+05. In the year 1973, what is the difference between the Number of enrolments of both sexes of Guatemala and Number of enrolments of both sexes of Romania?
Your answer should be compact. -2.05e+06. In the year 1973, what is the difference between the Number of enrolments of both sexes in Guatemala and Number of enrolments of both sexes in Togo?
Make the answer very short. 4.39e+04. In the year 1973, what is the difference between the Number of enrolments of both sexes of Myanmar and Number of enrolments of both sexes of Romania?
Ensure brevity in your answer.  -1.25e+06. In the year 1973, what is the difference between the Number of enrolments of both sexes in Myanmar and Number of enrolments of both sexes in Togo?
Give a very brief answer. 8.41e+05. In the year 1973, what is the difference between the Number of enrolments of both sexes in Romania and Number of enrolments of both sexes in Togo?
Your response must be concise. 2.09e+06. In the year 1991, what is the difference between the Number of enrolments of both sexes in Guatemala and Number of enrolments of both sexes in Myanmar?
Your response must be concise. -9.86e+05. In the year 1991, what is the difference between the Number of enrolments of both sexes in Guatemala and Number of enrolments of both sexes in Romania?
Offer a very short reply. -2.54e+06. In the year 1991, what is the difference between the Number of enrolments of both sexes in Guatemala and Number of enrolments of both sexes in Togo?
Offer a very short reply. 1.69e+05. In the year 1991, what is the difference between the Number of enrolments of both sexes in Myanmar and Number of enrolments of both sexes in Romania?
Ensure brevity in your answer.  -1.56e+06. In the year 1991, what is the difference between the Number of enrolments of both sexes of Myanmar and Number of enrolments of both sexes of Togo?
Offer a terse response. 1.16e+06. In the year 1991, what is the difference between the Number of enrolments of both sexes of Romania and Number of enrolments of both sexes of Togo?
Provide a short and direct response. 2.71e+06. In the year 1994, what is the difference between the Number of enrolments of both sexes of Guatemala and Number of enrolments of both sexes of Myanmar?
Keep it short and to the point. -1.17e+06. In the year 1994, what is the difference between the Number of enrolments of both sexes in Guatemala and Number of enrolments of both sexes in Romania?
Offer a terse response. -1.98e+06. In the year 1994, what is the difference between the Number of enrolments of both sexes of Guatemala and Number of enrolments of both sexes of Togo?
Give a very brief answer. 2.23e+05. In the year 1994, what is the difference between the Number of enrolments of both sexes of Myanmar and Number of enrolments of both sexes of Romania?
Offer a very short reply. -8.06e+05. In the year 1994, what is the difference between the Number of enrolments of both sexes of Myanmar and Number of enrolments of both sexes of Togo?
Provide a succinct answer. 1.40e+06. In the year 1994, what is the difference between the Number of enrolments of both sexes in Romania and Number of enrolments of both sexes in Togo?
Provide a short and direct response. 2.20e+06. In the year 1995, what is the difference between the Number of enrolments of both sexes in Guatemala and Number of enrolments of both sexes in Myanmar?
Ensure brevity in your answer.  -1.38e+06. In the year 1995, what is the difference between the Number of enrolments of both sexes in Guatemala and Number of enrolments of both sexes in Romania?
Offer a terse response. -1.88e+06. In the year 1995, what is the difference between the Number of enrolments of both sexes of Guatemala and Number of enrolments of both sexes of Togo?
Ensure brevity in your answer.  2.19e+05. In the year 1995, what is the difference between the Number of enrolments of both sexes in Myanmar and Number of enrolments of both sexes in Romania?
Your response must be concise. -5.00e+05. In the year 1995, what is the difference between the Number of enrolments of both sexes in Myanmar and Number of enrolments of both sexes in Togo?
Your response must be concise. 1.60e+06. In the year 1995, what is the difference between the Number of enrolments of both sexes of Romania and Number of enrolments of both sexes of Togo?
Keep it short and to the point. 2.10e+06. In the year 1999, what is the difference between the Number of enrolments of both sexes of Guatemala and Number of enrolments of both sexes of Myanmar?
Make the answer very short. -1.62e+06. In the year 1999, what is the difference between the Number of enrolments of both sexes in Guatemala and Number of enrolments of both sexes in Romania?
Offer a terse response. -1.78e+06. In the year 1999, what is the difference between the Number of enrolments of both sexes in Guatemala and Number of enrolments of both sexes in Togo?
Your answer should be compact. 2.03e+05. In the year 1999, what is the difference between the Number of enrolments of both sexes of Myanmar and Number of enrolments of both sexes of Romania?
Offer a very short reply. -1.59e+05. In the year 1999, what is the difference between the Number of enrolments of both sexes of Myanmar and Number of enrolments of both sexes of Togo?
Your answer should be compact. 1.83e+06. In the year 1999, what is the difference between the Number of enrolments of both sexes of Romania and Number of enrolments of both sexes of Togo?
Your response must be concise. 1.99e+06. In the year 2000, what is the difference between the Number of enrolments of both sexes of Guatemala and Number of enrolments of both sexes of Myanmar?
Your response must be concise. -1.76e+06. In the year 2000, what is the difference between the Number of enrolments of both sexes of Guatemala and Number of enrolments of both sexes of Romania?
Keep it short and to the point. -1.72e+06. In the year 2000, what is the difference between the Number of enrolments of both sexes in Guatemala and Number of enrolments of both sexes in Togo?
Offer a terse response. 2.45e+05. In the year 2000, what is the difference between the Number of enrolments of both sexes of Myanmar and Number of enrolments of both sexes of Romania?
Your response must be concise. 4.27e+04. In the year 2000, what is the difference between the Number of enrolments of both sexes in Myanmar and Number of enrolments of both sexes in Togo?
Your answer should be compact. 2.01e+06. In the year 2000, what is the difference between the Number of enrolments of both sexes in Romania and Number of enrolments of both sexes in Togo?
Your response must be concise. 1.97e+06. What is the ratio of the Number of enrolments of both sexes of Guatemala in 1971 to that in 1972?
Make the answer very short. 0.89. What is the ratio of the Number of enrolments of both sexes of Myanmar in 1971 to that in 1972?
Your answer should be very brief. 0.96. What is the ratio of the Number of enrolments of both sexes of Romania in 1971 to that in 1972?
Provide a succinct answer. 1.02. What is the ratio of the Number of enrolments of both sexes of Togo in 1971 to that in 1972?
Your response must be concise. 0.81. What is the ratio of the Number of enrolments of both sexes in Guatemala in 1971 to that in 1973?
Ensure brevity in your answer.  0.87. What is the ratio of the Number of enrolments of both sexes in Myanmar in 1971 to that in 1973?
Ensure brevity in your answer.  0.91. What is the ratio of the Number of enrolments of both sexes in Togo in 1971 to that in 1973?
Provide a succinct answer. 0.7. What is the ratio of the Number of enrolments of both sexes in Guatemala in 1971 to that in 1991?
Ensure brevity in your answer.  0.22. What is the ratio of the Number of enrolments of both sexes of Myanmar in 1971 to that in 1991?
Keep it short and to the point. 0.62. What is the ratio of the Number of enrolments of both sexes of Romania in 1971 to that in 1991?
Your response must be concise. 0.75. What is the ratio of the Number of enrolments of both sexes of Togo in 1971 to that in 1991?
Make the answer very short. 0.18. What is the ratio of the Number of enrolments of both sexes of Guatemala in 1971 to that in 1994?
Your answer should be very brief. 0.18. What is the ratio of the Number of enrolments of both sexes of Myanmar in 1971 to that in 1994?
Provide a succinct answer. 0.52. What is the ratio of the Number of enrolments of both sexes of Romania in 1971 to that in 1994?
Your response must be concise. 0.92. What is the ratio of the Number of enrolments of both sexes in Togo in 1971 to that in 1994?
Your answer should be compact. 0.16. What is the ratio of the Number of enrolments of both sexes in Guatemala in 1971 to that in 1995?
Your answer should be compact. 0.18. What is the ratio of the Number of enrolments of both sexes in Myanmar in 1971 to that in 1995?
Offer a terse response. 0.45. What is the ratio of the Number of enrolments of both sexes in Romania in 1971 to that in 1995?
Offer a very short reply. 0.95. What is the ratio of the Number of enrolments of both sexes in Togo in 1971 to that in 1995?
Provide a short and direct response. 0.14. What is the ratio of the Number of enrolments of both sexes in Guatemala in 1971 to that in 1999?
Your answer should be very brief. 0.15. What is the ratio of the Number of enrolments of both sexes of Myanmar in 1971 to that in 1999?
Provide a short and direct response. 0.38. What is the ratio of the Number of enrolments of both sexes in Romania in 1971 to that in 1999?
Keep it short and to the point. 0.96. What is the ratio of the Number of enrolments of both sexes in Togo in 1971 to that in 1999?
Ensure brevity in your answer.  0.09. What is the ratio of the Number of enrolments of both sexes in Guatemala in 1971 to that in 2000?
Provide a short and direct response. 0.13. What is the ratio of the Number of enrolments of both sexes of Myanmar in 1971 to that in 2000?
Ensure brevity in your answer.  0.35. What is the ratio of the Number of enrolments of both sexes in Romania in 1971 to that in 2000?
Offer a terse response. 0.96. What is the ratio of the Number of enrolments of both sexes of Togo in 1971 to that in 2000?
Your answer should be compact. 0.09. What is the ratio of the Number of enrolments of both sexes in Guatemala in 1972 to that in 1973?
Make the answer very short. 0.98. What is the ratio of the Number of enrolments of both sexes in Myanmar in 1972 to that in 1973?
Offer a terse response. 0.94. What is the ratio of the Number of enrolments of both sexes in Romania in 1972 to that in 1973?
Provide a short and direct response. 0.99. What is the ratio of the Number of enrolments of both sexes in Togo in 1972 to that in 1973?
Provide a succinct answer. 0.87. What is the ratio of the Number of enrolments of both sexes in Guatemala in 1972 to that in 1991?
Provide a short and direct response. 0.25. What is the ratio of the Number of enrolments of both sexes in Myanmar in 1972 to that in 1991?
Ensure brevity in your answer.  0.64. What is the ratio of the Number of enrolments of both sexes in Romania in 1972 to that in 1991?
Your answer should be compact. 0.74. What is the ratio of the Number of enrolments of both sexes of Togo in 1972 to that in 1991?
Ensure brevity in your answer.  0.22. What is the ratio of the Number of enrolments of both sexes of Guatemala in 1972 to that in 1994?
Ensure brevity in your answer.  0.21. What is the ratio of the Number of enrolments of both sexes in Myanmar in 1972 to that in 1994?
Your answer should be very brief. 0.54. What is the ratio of the Number of enrolments of both sexes in Romania in 1972 to that in 1994?
Keep it short and to the point. 0.9. What is the ratio of the Number of enrolments of both sexes in Togo in 1972 to that in 1994?
Provide a short and direct response. 0.2. What is the ratio of the Number of enrolments of both sexes of Guatemala in 1972 to that in 1995?
Provide a succinct answer. 0.2. What is the ratio of the Number of enrolments of both sexes in Myanmar in 1972 to that in 1995?
Offer a terse response. 0.47. What is the ratio of the Number of enrolments of both sexes in Romania in 1972 to that in 1995?
Offer a terse response. 0.93. What is the ratio of the Number of enrolments of both sexes of Togo in 1972 to that in 1995?
Give a very brief answer. 0.18. What is the ratio of the Number of enrolments of both sexes in Guatemala in 1972 to that in 1999?
Your answer should be very brief. 0.17. What is the ratio of the Number of enrolments of both sexes of Myanmar in 1972 to that in 1999?
Provide a short and direct response. 0.4. What is the ratio of the Number of enrolments of both sexes of Romania in 1972 to that in 1999?
Keep it short and to the point. 0.94. What is the ratio of the Number of enrolments of both sexes of Togo in 1972 to that in 1999?
Make the answer very short. 0.12. What is the ratio of the Number of enrolments of both sexes of Guatemala in 1972 to that in 2000?
Ensure brevity in your answer.  0.15. What is the ratio of the Number of enrolments of both sexes of Myanmar in 1972 to that in 2000?
Provide a succinct answer. 0.36. What is the ratio of the Number of enrolments of both sexes of Romania in 1972 to that in 2000?
Offer a very short reply. 0.94. What is the ratio of the Number of enrolments of both sexes in Togo in 1972 to that in 2000?
Give a very brief answer. 0.11. What is the ratio of the Number of enrolments of both sexes of Guatemala in 1973 to that in 1991?
Provide a short and direct response. 0.25. What is the ratio of the Number of enrolments of both sexes in Myanmar in 1973 to that in 1991?
Your answer should be very brief. 0.68. What is the ratio of the Number of enrolments of both sexes in Romania in 1973 to that in 1991?
Provide a succinct answer. 0.75. What is the ratio of the Number of enrolments of both sexes in Togo in 1973 to that in 1991?
Your answer should be compact. 0.25. What is the ratio of the Number of enrolments of both sexes in Guatemala in 1973 to that in 1994?
Ensure brevity in your answer.  0.21. What is the ratio of the Number of enrolments of both sexes in Myanmar in 1973 to that in 1994?
Your response must be concise. 0.57. What is the ratio of the Number of enrolments of both sexes of Romania in 1973 to that in 1994?
Provide a short and direct response. 0.91. What is the ratio of the Number of enrolments of both sexes in Togo in 1973 to that in 1994?
Give a very brief answer. 0.23. What is the ratio of the Number of enrolments of both sexes in Guatemala in 1973 to that in 1995?
Ensure brevity in your answer.  0.2. What is the ratio of the Number of enrolments of both sexes in Myanmar in 1973 to that in 1995?
Offer a terse response. 0.5. What is the ratio of the Number of enrolments of both sexes of Romania in 1973 to that in 1995?
Provide a succinct answer. 0.94. What is the ratio of the Number of enrolments of both sexes of Togo in 1973 to that in 1995?
Keep it short and to the point. 0.2. What is the ratio of the Number of enrolments of both sexes in Guatemala in 1973 to that in 1999?
Provide a succinct answer. 0.17. What is the ratio of the Number of enrolments of both sexes of Myanmar in 1973 to that in 1999?
Your answer should be very brief. 0.42. What is the ratio of the Number of enrolments of both sexes of Romania in 1973 to that in 1999?
Ensure brevity in your answer.  0.96. What is the ratio of the Number of enrolments of both sexes in Togo in 1973 to that in 1999?
Provide a short and direct response. 0.13. What is the ratio of the Number of enrolments of both sexes in Guatemala in 1973 to that in 2000?
Offer a terse response. 0.15. What is the ratio of the Number of enrolments of both sexes in Myanmar in 1973 to that in 2000?
Offer a terse response. 0.38. What is the ratio of the Number of enrolments of both sexes of Romania in 1973 to that in 2000?
Keep it short and to the point. 0.95. What is the ratio of the Number of enrolments of both sexes in Togo in 1973 to that in 2000?
Provide a short and direct response. 0.12. What is the ratio of the Number of enrolments of both sexes of Guatemala in 1991 to that in 1994?
Your answer should be compact. 0.82. What is the ratio of the Number of enrolments of both sexes in Myanmar in 1991 to that in 1994?
Ensure brevity in your answer.  0.84. What is the ratio of the Number of enrolments of both sexes in Romania in 1991 to that in 1994?
Offer a very short reply. 1.21. What is the ratio of the Number of enrolments of both sexes in Togo in 1991 to that in 1994?
Ensure brevity in your answer.  0.93. What is the ratio of the Number of enrolments of both sexes in Guatemala in 1991 to that in 1995?
Your answer should be very brief. 0.79. What is the ratio of the Number of enrolments of both sexes of Myanmar in 1991 to that in 1995?
Offer a very short reply. 0.73. What is the ratio of the Number of enrolments of both sexes in Romania in 1991 to that in 1995?
Offer a terse response. 1.26. What is the ratio of the Number of enrolments of both sexes in Togo in 1991 to that in 1995?
Offer a terse response. 0.82. What is the ratio of the Number of enrolments of both sexes of Guatemala in 1991 to that in 1999?
Offer a terse response. 0.68. What is the ratio of the Number of enrolments of both sexes in Myanmar in 1991 to that in 1999?
Give a very brief answer. 0.62. What is the ratio of the Number of enrolments of both sexes in Romania in 1991 to that in 1999?
Offer a very short reply. 1.28. What is the ratio of the Number of enrolments of both sexes in Togo in 1991 to that in 1999?
Your answer should be compact. 0.54. What is the ratio of the Number of enrolments of both sexes of Guatemala in 1991 to that in 2000?
Give a very brief answer. 0.59. What is the ratio of the Number of enrolments of both sexes in Myanmar in 1991 to that in 2000?
Your response must be concise. 0.56. What is the ratio of the Number of enrolments of both sexes in Romania in 1991 to that in 2000?
Your response must be concise. 1.28. What is the ratio of the Number of enrolments of both sexes in Togo in 1991 to that in 2000?
Offer a very short reply. 0.49. What is the ratio of the Number of enrolments of both sexes of Guatemala in 1994 to that in 1995?
Offer a terse response. 0.96. What is the ratio of the Number of enrolments of both sexes of Myanmar in 1994 to that in 1995?
Keep it short and to the point. 0.87. What is the ratio of the Number of enrolments of both sexes of Romania in 1994 to that in 1995?
Your response must be concise. 1.04. What is the ratio of the Number of enrolments of both sexes of Togo in 1994 to that in 1995?
Keep it short and to the point. 0.88. What is the ratio of the Number of enrolments of both sexes of Guatemala in 1994 to that in 1999?
Provide a short and direct response. 0.82. What is the ratio of the Number of enrolments of both sexes in Myanmar in 1994 to that in 1999?
Provide a short and direct response. 0.74. What is the ratio of the Number of enrolments of both sexes in Romania in 1994 to that in 1999?
Keep it short and to the point. 1.05. What is the ratio of the Number of enrolments of both sexes of Togo in 1994 to that in 1999?
Offer a very short reply. 0.58. What is the ratio of the Number of enrolments of both sexes in Guatemala in 1994 to that in 2000?
Give a very brief answer. 0.71. What is the ratio of the Number of enrolments of both sexes of Myanmar in 1994 to that in 2000?
Ensure brevity in your answer.  0.67. What is the ratio of the Number of enrolments of both sexes of Romania in 1994 to that in 2000?
Ensure brevity in your answer.  1.05. What is the ratio of the Number of enrolments of both sexes of Togo in 1994 to that in 2000?
Your answer should be compact. 0.52. What is the ratio of the Number of enrolments of both sexes in Guatemala in 1995 to that in 1999?
Your answer should be compact. 0.86. What is the ratio of the Number of enrolments of both sexes of Myanmar in 1995 to that in 1999?
Make the answer very short. 0.85. What is the ratio of the Number of enrolments of both sexes of Romania in 1995 to that in 1999?
Provide a succinct answer. 1.02. What is the ratio of the Number of enrolments of both sexes of Togo in 1995 to that in 1999?
Give a very brief answer. 0.66. What is the ratio of the Number of enrolments of both sexes in Guatemala in 1995 to that in 2000?
Your response must be concise. 0.74. What is the ratio of the Number of enrolments of both sexes of Myanmar in 1995 to that in 2000?
Your answer should be compact. 0.77. What is the ratio of the Number of enrolments of both sexes of Romania in 1995 to that in 2000?
Make the answer very short. 1.01. What is the ratio of the Number of enrolments of both sexes in Togo in 1995 to that in 2000?
Give a very brief answer. 0.59. What is the ratio of the Number of enrolments of both sexes of Guatemala in 1999 to that in 2000?
Offer a very short reply. 0.86. What is the ratio of the Number of enrolments of both sexes of Myanmar in 1999 to that in 2000?
Offer a terse response. 0.91. What is the ratio of the Number of enrolments of both sexes in Romania in 1999 to that in 2000?
Offer a terse response. 1. What is the ratio of the Number of enrolments of both sexes of Togo in 1999 to that in 2000?
Your answer should be compact. 0.9. What is the difference between the highest and the second highest Number of enrolments of both sexes in Guatemala?
Keep it short and to the point. 6.90e+04. What is the difference between the highest and the second highest Number of enrolments of both sexes in Myanmar?
Your answer should be compact. 2.09e+05. What is the difference between the highest and the second highest Number of enrolments of both sexes of Romania?
Offer a very short reply. 5.02e+05. What is the difference between the highest and the second highest Number of enrolments of both sexes in Togo?
Provide a short and direct response. 2.67e+04. What is the difference between the highest and the lowest Number of enrolments of both sexes in Guatemala?
Offer a very short reply. 4.38e+05. What is the difference between the highest and the lowest Number of enrolments of both sexes of Myanmar?
Your answer should be very brief. 1.48e+06. What is the difference between the highest and the lowest Number of enrolments of both sexes in Romania?
Offer a terse response. 7.44e+05. What is the difference between the highest and the lowest Number of enrolments of both sexes of Togo?
Offer a terse response. 2.37e+05. 